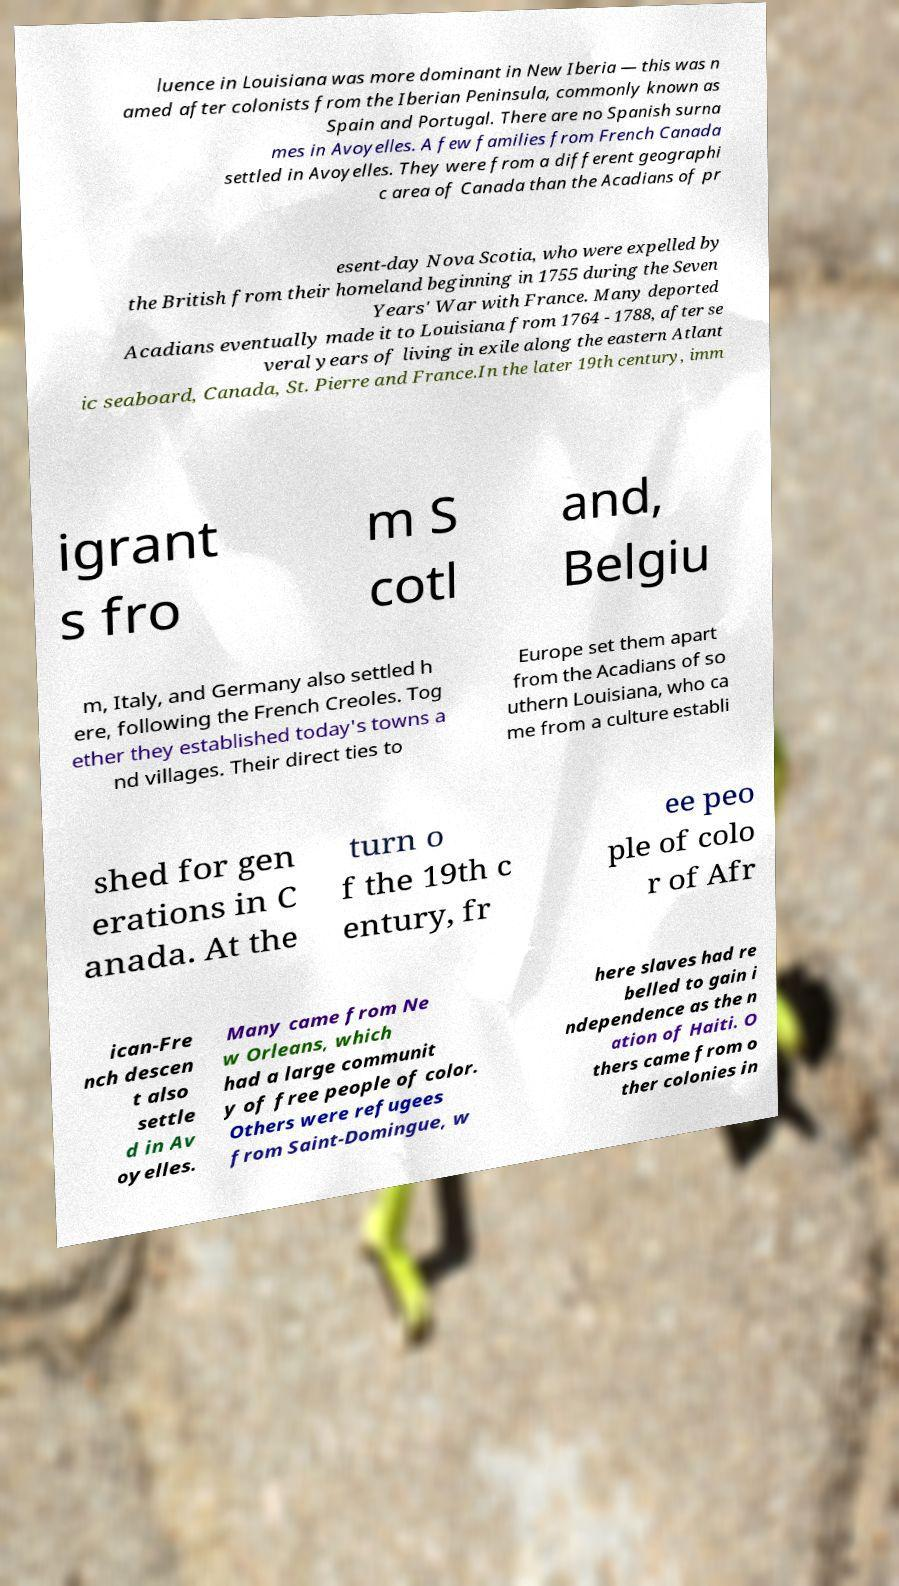I need the written content from this picture converted into text. Can you do that? luence in Louisiana was more dominant in New Iberia — this was n amed after colonists from the Iberian Peninsula, commonly known as Spain and Portugal. There are no Spanish surna mes in Avoyelles. A few families from French Canada settled in Avoyelles. They were from a different geographi c area of Canada than the Acadians of pr esent-day Nova Scotia, who were expelled by the British from their homeland beginning in 1755 during the Seven Years' War with France. Many deported Acadians eventually made it to Louisiana from 1764 - 1788, after se veral years of living in exile along the eastern Atlant ic seaboard, Canada, St. Pierre and France.In the later 19th century, imm igrant s fro m S cotl and, Belgiu m, Italy, and Germany also settled h ere, following the French Creoles. Tog ether they established today's towns a nd villages. Their direct ties to Europe set them apart from the Acadians of so uthern Louisiana, who ca me from a culture establi shed for gen erations in C anada. At the turn o f the 19th c entury, fr ee peo ple of colo r of Afr ican-Fre nch descen t also settle d in Av oyelles. Many came from Ne w Orleans, which had a large communit y of free people of color. Others were refugees from Saint-Domingue, w here slaves had re belled to gain i ndependence as the n ation of Haiti. O thers came from o ther colonies in 